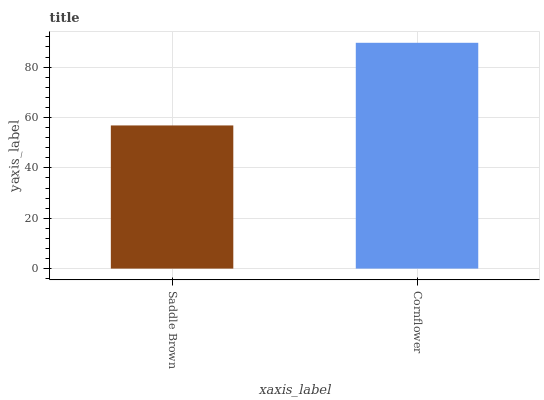Is Saddle Brown the minimum?
Answer yes or no. Yes. Is Cornflower the maximum?
Answer yes or no. Yes. Is Cornflower the minimum?
Answer yes or no. No. Is Cornflower greater than Saddle Brown?
Answer yes or no. Yes. Is Saddle Brown less than Cornflower?
Answer yes or no. Yes. Is Saddle Brown greater than Cornflower?
Answer yes or no. No. Is Cornflower less than Saddle Brown?
Answer yes or no. No. Is Cornflower the high median?
Answer yes or no. Yes. Is Saddle Brown the low median?
Answer yes or no. Yes. Is Saddle Brown the high median?
Answer yes or no. No. Is Cornflower the low median?
Answer yes or no. No. 